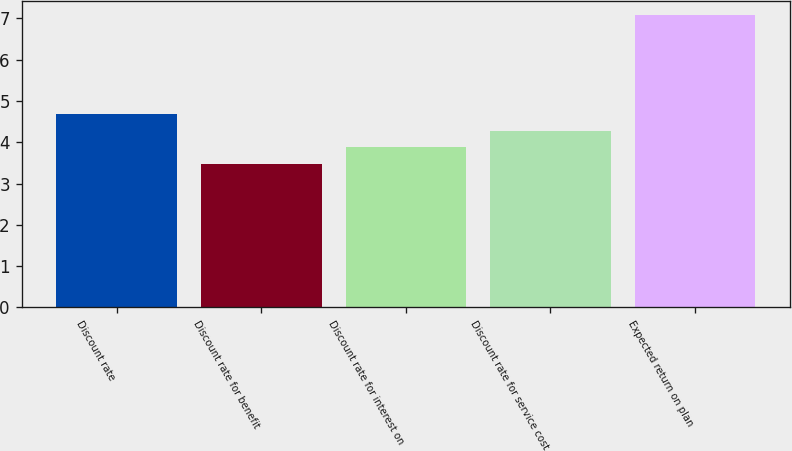Convert chart to OTSL. <chart><loc_0><loc_0><loc_500><loc_500><bar_chart><fcel>Discount rate<fcel>Discount rate for benefit<fcel>Discount rate for interest on<fcel>Discount rate for service cost<fcel>Expected return on plan<nl><fcel>4.68<fcel>3.48<fcel>3.88<fcel>4.28<fcel>7.08<nl></chart> 